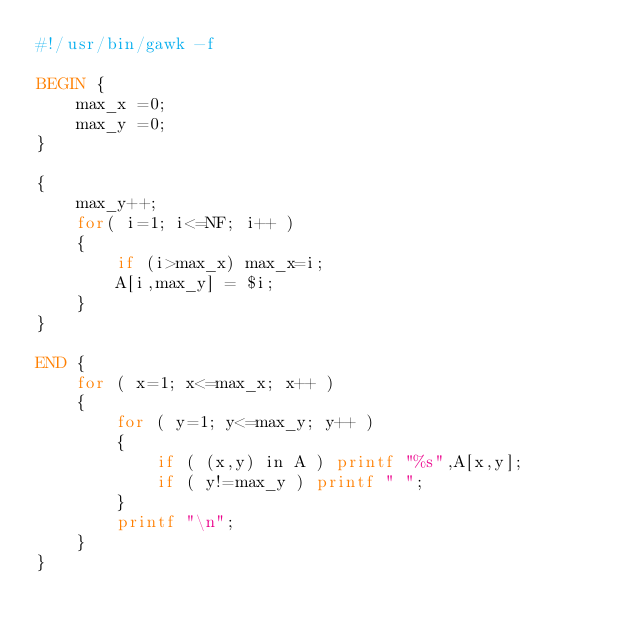<code> <loc_0><loc_0><loc_500><loc_500><_Awk_>#!/usr/bin/gawk -f

BEGIN {
    max_x =0;
    max_y =0;
}

{
    max_y++;
    for( i=1; i<=NF; i++ )
    {
        if (i>max_x) max_x=i;
        A[i,max_y] = $i;
    }
}

END {
    for ( x=1; x<=max_x; x++ )
    {
        for ( y=1; y<=max_y; y++ )
        {
            if ( (x,y) in A ) printf "%s",A[x,y];
            if ( y!=max_y ) printf " ";
        }
        printf "\n";
    }
}
</code> 